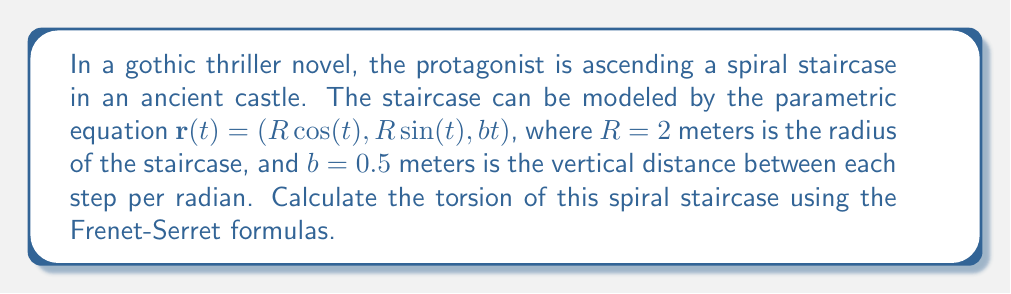Solve this math problem. To calculate the torsion of the spiral staircase, we'll use the Frenet-Serret formulas. The steps are as follows:

1) First, we need to find $\mathbf{r}'(t)$, $\mathbf{r}''(t)$, and $\mathbf{r}'''(t)$:

   $\mathbf{r}'(t) = (-2\sin(t), 2\cos(t), 0.5)$
   $\mathbf{r}''(t) = (-2\cos(t), -2\sin(t), 0)$
   $\mathbf{r}'''(t) = (2\sin(t), -2\cos(t), 0)$

2) The torsion $\tau$ is given by the formula:

   $$\tau = \frac{\mathbf{r}'(t) \cdot (\mathbf{r}''(t) \times \mathbf{r}'''(t))}{|\mathbf{r}'(t) \times \mathbf{r}''(t)|^2}$$

3) Let's calculate the cross product $\mathbf{r}''(t) \times \mathbf{r}'''(t)$:

   $\mathbf{r}''(t) \times \mathbf{r}'''(t) = (0, 0, -8)$

4) Now, let's calculate the dot product in the numerator:

   $\mathbf{r}'(t) \cdot (\mathbf{r}''(t) \times \mathbf{r}'''(t)) = (-2\sin(t), 2\cos(t), 0.5) \cdot (0, 0, -8) = -4$

5) For the denominator, we need to calculate $\mathbf{r}'(t) \times \mathbf{r}''(t)$:

   $\mathbf{r}'(t) \times \mathbf{r}''(t) = (-1\cos(t), -1\sin(t), 4)$

6) The magnitude squared of this vector is:

   $|\mathbf{r}'(t) \times \mathbf{r}''(t)|^2 = (-1\cos(t))^2 + (-1\sin(t))^2 + 4^2 = 1 + 16 = 17$

7) Finally, we can calculate the torsion:

   $$\tau = \frac{-4}{17} = -\frac{4}{17}$$

The negative sign indicates that the staircase is a right-handed helix.
Answer: $-\frac{4}{17}$ m$^{-1}$ 